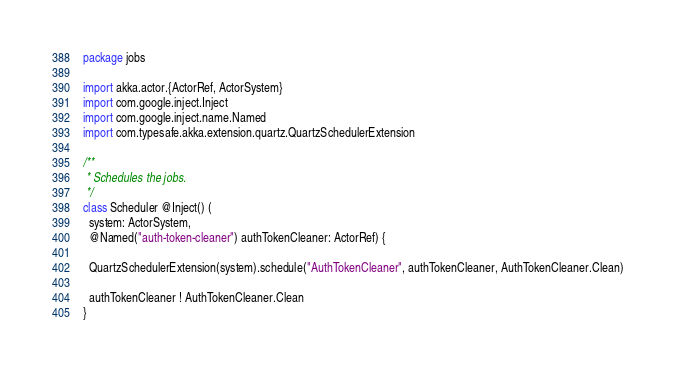Convert code to text. <code><loc_0><loc_0><loc_500><loc_500><_Scala_>package jobs

import akka.actor.{ActorRef, ActorSystem}
import com.google.inject.Inject
import com.google.inject.name.Named
import com.typesafe.akka.extension.quartz.QuartzSchedulerExtension

/**
 * Schedules the jobs.
 */
class Scheduler @Inject() (
  system: ActorSystem,
  @Named("auth-token-cleaner") authTokenCleaner: ActorRef) {

  QuartzSchedulerExtension(system).schedule("AuthTokenCleaner", authTokenCleaner, AuthTokenCleaner.Clean)

  authTokenCleaner ! AuthTokenCleaner.Clean
}
</code> 